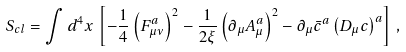<formula> <loc_0><loc_0><loc_500><loc_500>S _ { c l } = \int d ^ { 4 } x \, \left [ - \frac { 1 } { 4 } \left ( F _ { \mu \nu } ^ { a } \right ) ^ { 2 } - \frac { 1 } { 2 \xi } \left ( \partial _ { \mu } A _ { \mu } ^ { a } \right ) ^ { 2 } - \partial _ { \mu } \bar { c } ^ { a } \left ( D _ { \mu } c \right ) ^ { a } \right ] \, ,</formula> 